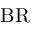Convert formula to latex. <formula><loc_0><loc_0><loc_500><loc_500>B R</formula> 